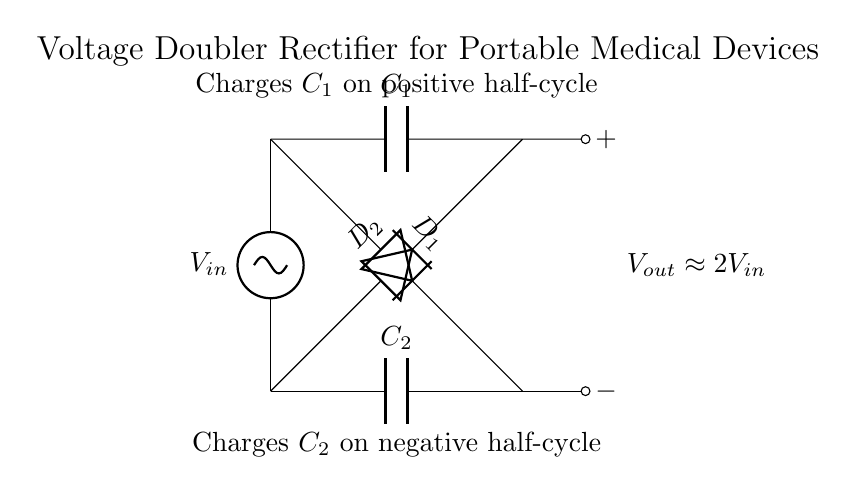What does this circuit do? This circuit is a voltage doubler rectifier which takes an AC input and provides a DC output that is approximately double the input voltage. This is indicated by the output voltage label showing "Vout approximately 2Vin".
Answer: Voltage doubler How many capacitors are in this circuit? There are two capacitors shown in the circuit, labeled C1 and C2.
Answer: Two capacitors What is the function of the diodes in this circuit? The diodes, labeled D1 and D2, are used to allow current to flow in one direction only, enabling the charging of the capacitors during their respective half-cycles of the AC input.
Answer: Rectification What is the approximate output voltage if the input voltage is 5 volts? The output voltage is approximately double the input voltage. Thus, if Vin is 5 volts, Vout would be approximately 10 volts.
Answer: 10 volts What happens to C2 during the negative half-cycle? C2 charges during the negative half-cycle of the AC input since it connects to the output in that period, which allows negative voltage to contribute to its charge.
Answer: Charges Why is this circuit suitable for portable medical devices? This circuit is compact and can efficiently convert standard AC sources to a higher DC voltage, which is ideal for the low power requirements and space constraints of portable medical devices.
Answer: Compact and efficient 